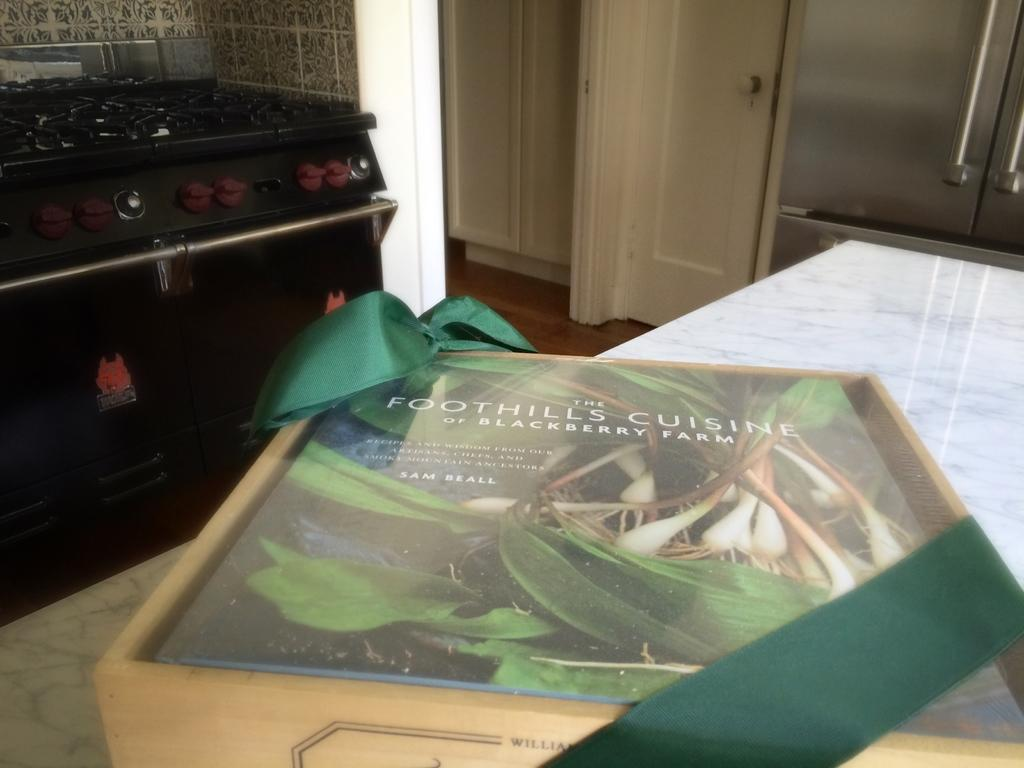<image>
Present a compact description of the photo's key features. A book titled Foothills Cuisine sitting on a marble counter in a kitchen. 